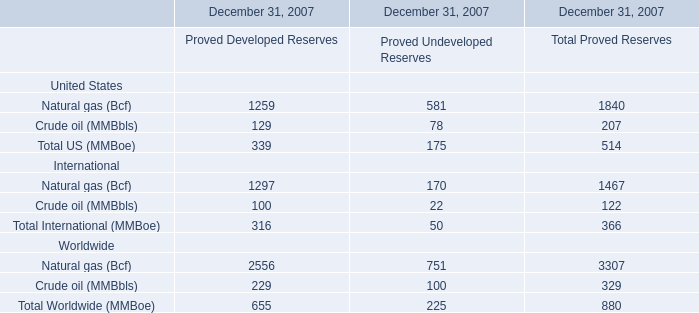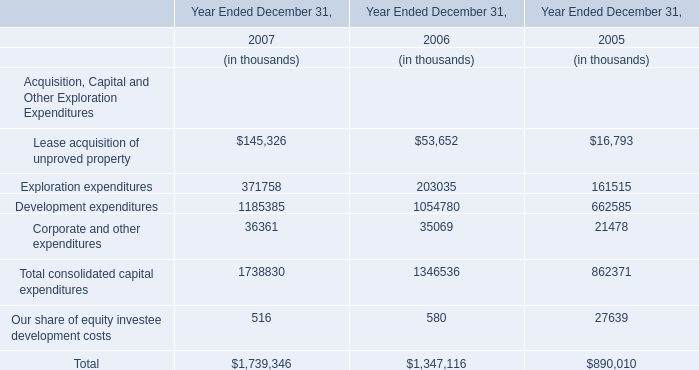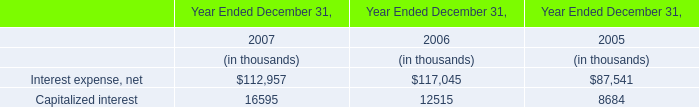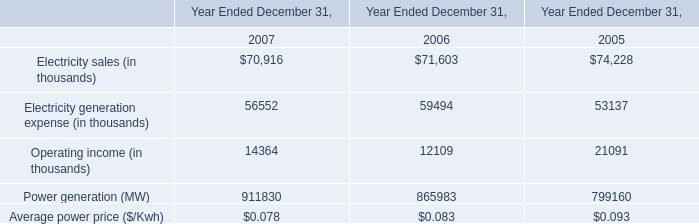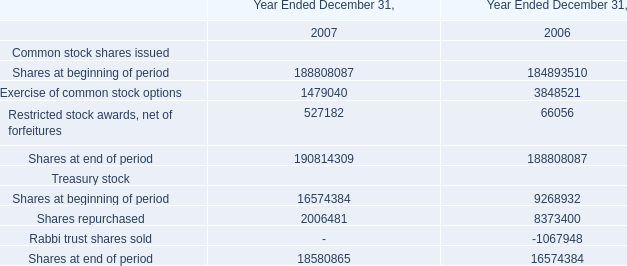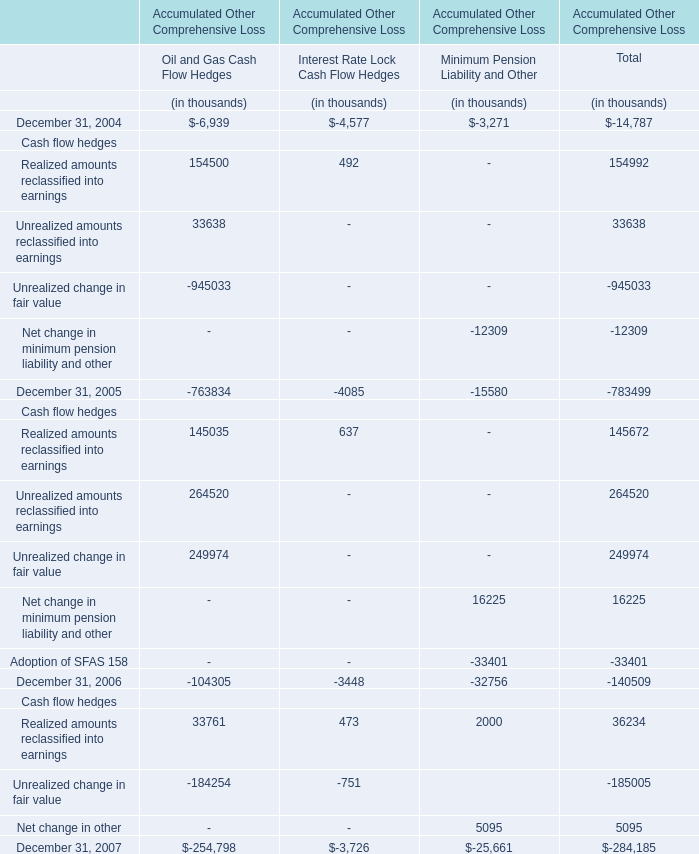In the year with the greatest proportion of Oil and Gas Cash Flow Hedges, what is the proportion of Oil and Gas Cash Flow Hedgesto the tatal? 
Computations: (763834 / 783499)
Answer: 0.9749. 